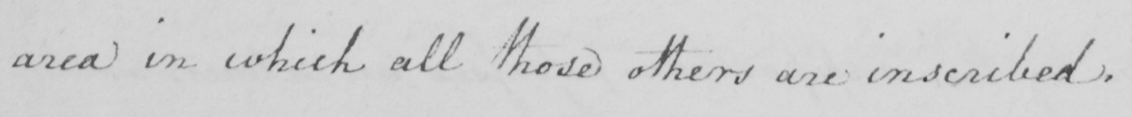What is written in this line of handwriting? area in which all those others are inscribed . 